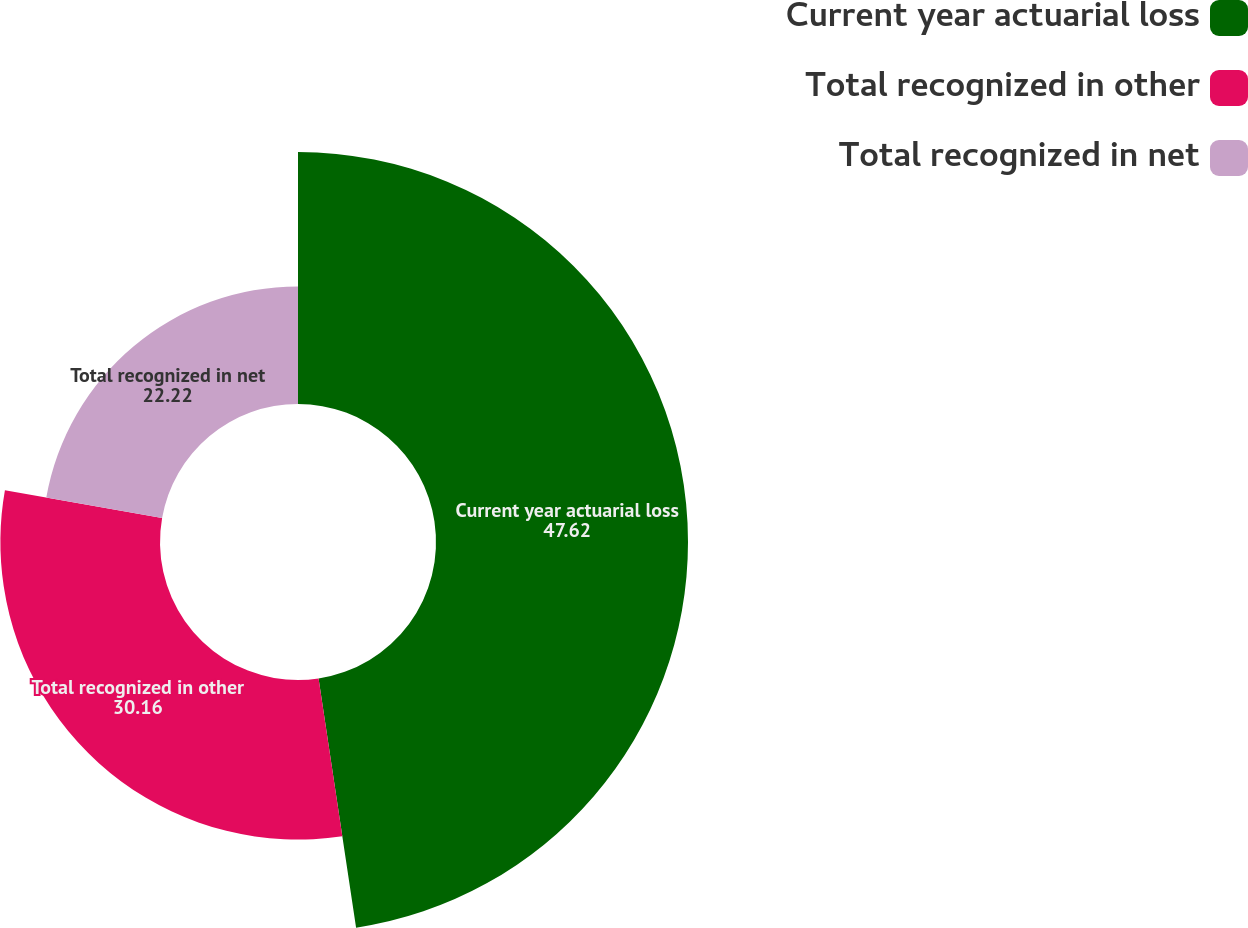<chart> <loc_0><loc_0><loc_500><loc_500><pie_chart><fcel>Current year actuarial loss<fcel>Total recognized in other<fcel>Total recognized in net<nl><fcel>47.62%<fcel>30.16%<fcel>22.22%<nl></chart> 